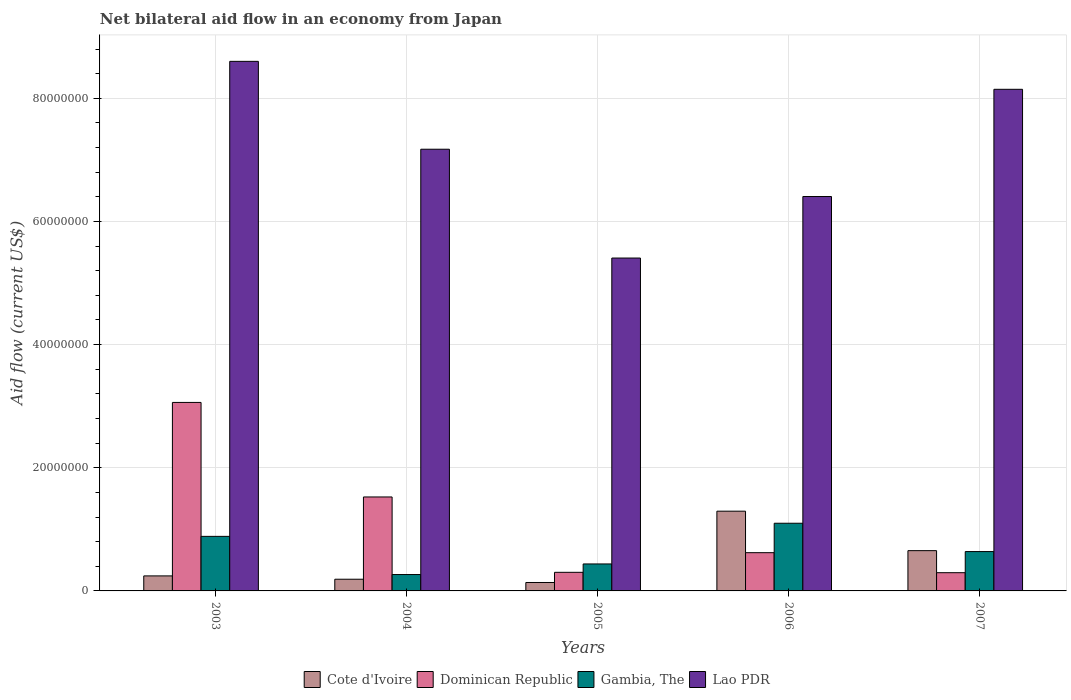How many different coloured bars are there?
Offer a very short reply. 4. How many groups of bars are there?
Give a very brief answer. 5. Are the number of bars per tick equal to the number of legend labels?
Offer a terse response. Yes. What is the label of the 1st group of bars from the left?
Provide a short and direct response. 2003. What is the net bilateral aid flow in Lao PDR in 2004?
Provide a short and direct response. 7.17e+07. Across all years, what is the maximum net bilateral aid flow in Gambia, The?
Provide a succinct answer. 1.10e+07. Across all years, what is the minimum net bilateral aid flow in Gambia, The?
Provide a succinct answer. 2.66e+06. In which year was the net bilateral aid flow in Gambia, The minimum?
Your answer should be very brief. 2004. What is the total net bilateral aid flow in Lao PDR in the graph?
Your response must be concise. 3.57e+08. What is the difference between the net bilateral aid flow in Gambia, The in 2003 and that in 2007?
Offer a very short reply. 2.47e+06. What is the difference between the net bilateral aid flow in Dominican Republic in 2007 and the net bilateral aid flow in Gambia, The in 2003?
Keep it short and to the point. -5.90e+06. What is the average net bilateral aid flow in Dominican Republic per year?
Ensure brevity in your answer.  1.16e+07. In the year 2007, what is the difference between the net bilateral aid flow in Gambia, The and net bilateral aid flow in Cote d'Ivoire?
Make the answer very short. -1.50e+05. What is the ratio of the net bilateral aid flow in Lao PDR in 2004 to that in 2007?
Keep it short and to the point. 0.88. Is the net bilateral aid flow in Cote d'Ivoire in 2003 less than that in 2006?
Offer a terse response. Yes. Is the difference between the net bilateral aid flow in Gambia, The in 2003 and 2004 greater than the difference between the net bilateral aid flow in Cote d'Ivoire in 2003 and 2004?
Provide a short and direct response. Yes. What is the difference between the highest and the second highest net bilateral aid flow in Dominican Republic?
Give a very brief answer. 1.54e+07. What is the difference between the highest and the lowest net bilateral aid flow in Cote d'Ivoire?
Make the answer very short. 1.16e+07. In how many years, is the net bilateral aid flow in Dominican Republic greater than the average net bilateral aid flow in Dominican Republic taken over all years?
Provide a succinct answer. 2. Is the sum of the net bilateral aid flow in Cote d'Ivoire in 2004 and 2006 greater than the maximum net bilateral aid flow in Dominican Republic across all years?
Offer a very short reply. No. What does the 4th bar from the left in 2004 represents?
Provide a succinct answer. Lao PDR. What does the 4th bar from the right in 2006 represents?
Make the answer very short. Cote d'Ivoire. Are all the bars in the graph horizontal?
Give a very brief answer. No. How many years are there in the graph?
Make the answer very short. 5. What is the difference between two consecutive major ticks on the Y-axis?
Your answer should be very brief. 2.00e+07. Are the values on the major ticks of Y-axis written in scientific E-notation?
Your response must be concise. No. Does the graph contain grids?
Your answer should be very brief. Yes. Where does the legend appear in the graph?
Your answer should be compact. Bottom center. What is the title of the graph?
Your answer should be very brief. Net bilateral aid flow in an economy from Japan. Does "Iran" appear as one of the legend labels in the graph?
Give a very brief answer. No. What is the label or title of the Y-axis?
Keep it short and to the point. Aid flow (current US$). What is the Aid flow (current US$) in Cote d'Ivoire in 2003?
Your response must be concise. 2.44e+06. What is the Aid flow (current US$) in Dominican Republic in 2003?
Your response must be concise. 3.06e+07. What is the Aid flow (current US$) in Gambia, The in 2003?
Provide a short and direct response. 8.86e+06. What is the Aid flow (current US$) of Lao PDR in 2003?
Provide a succinct answer. 8.60e+07. What is the Aid flow (current US$) of Cote d'Ivoire in 2004?
Offer a very short reply. 1.90e+06. What is the Aid flow (current US$) of Dominican Republic in 2004?
Provide a short and direct response. 1.53e+07. What is the Aid flow (current US$) in Gambia, The in 2004?
Make the answer very short. 2.66e+06. What is the Aid flow (current US$) of Lao PDR in 2004?
Give a very brief answer. 7.17e+07. What is the Aid flow (current US$) in Cote d'Ivoire in 2005?
Ensure brevity in your answer.  1.37e+06. What is the Aid flow (current US$) in Dominican Republic in 2005?
Your answer should be very brief. 3.02e+06. What is the Aid flow (current US$) of Gambia, The in 2005?
Keep it short and to the point. 4.38e+06. What is the Aid flow (current US$) in Lao PDR in 2005?
Provide a succinct answer. 5.41e+07. What is the Aid flow (current US$) in Cote d'Ivoire in 2006?
Keep it short and to the point. 1.30e+07. What is the Aid flow (current US$) in Dominican Republic in 2006?
Offer a very short reply. 6.21e+06. What is the Aid flow (current US$) in Gambia, The in 2006?
Offer a very short reply. 1.10e+07. What is the Aid flow (current US$) in Lao PDR in 2006?
Offer a terse response. 6.40e+07. What is the Aid flow (current US$) of Cote d'Ivoire in 2007?
Ensure brevity in your answer.  6.54e+06. What is the Aid flow (current US$) in Dominican Republic in 2007?
Your response must be concise. 2.96e+06. What is the Aid flow (current US$) of Gambia, The in 2007?
Make the answer very short. 6.39e+06. What is the Aid flow (current US$) of Lao PDR in 2007?
Give a very brief answer. 8.15e+07. Across all years, what is the maximum Aid flow (current US$) in Cote d'Ivoire?
Provide a short and direct response. 1.30e+07. Across all years, what is the maximum Aid flow (current US$) of Dominican Republic?
Offer a very short reply. 3.06e+07. Across all years, what is the maximum Aid flow (current US$) of Gambia, The?
Your answer should be very brief. 1.10e+07. Across all years, what is the maximum Aid flow (current US$) in Lao PDR?
Give a very brief answer. 8.60e+07. Across all years, what is the minimum Aid flow (current US$) of Cote d'Ivoire?
Make the answer very short. 1.37e+06. Across all years, what is the minimum Aid flow (current US$) in Dominican Republic?
Your answer should be compact. 2.96e+06. Across all years, what is the minimum Aid flow (current US$) in Gambia, The?
Provide a succinct answer. 2.66e+06. Across all years, what is the minimum Aid flow (current US$) of Lao PDR?
Ensure brevity in your answer.  5.41e+07. What is the total Aid flow (current US$) in Cote d'Ivoire in the graph?
Give a very brief answer. 2.52e+07. What is the total Aid flow (current US$) in Dominican Republic in the graph?
Your answer should be compact. 5.81e+07. What is the total Aid flow (current US$) of Gambia, The in the graph?
Offer a very short reply. 3.33e+07. What is the total Aid flow (current US$) in Lao PDR in the graph?
Your answer should be compact. 3.57e+08. What is the difference between the Aid flow (current US$) in Cote d'Ivoire in 2003 and that in 2004?
Your answer should be very brief. 5.40e+05. What is the difference between the Aid flow (current US$) in Dominican Republic in 2003 and that in 2004?
Your answer should be compact. 1.54e+07. What is the difference between the Aid flow (current US$) of Gambia, The in 2003 and that in 2004?
Ensure brevity in your answer.  6.20e+06. What is the difference between the Aid flow (current US$) in Lao PDR in 2003 and that in 2004?
Offer a very short reply. 1.43e+07. What is the difference between the Aid flow (current US$) of Cote d'Ivoire in 2003 and that in 2005?
Offer a terse response. 1.07e+06. What is the difference between the Aid flow (current US$) of Dominican Republic in 2003 and that in 2005?
Your answer should be very brief. 2.76e+07. What is the difference between the Aid flow (current US$) of Gambia, The in 2003 and that in 2005?
Keep it short and to the point. 4.48e+06. What is the difference between the Aid flow (current US$) of Lao PDR in 2003 and that in 2005?
Offer a very short reply. 3.19e+07. What is the difference between the Aid flow (current US$) in Cote d'Ivoire in 2003 and that in 2006?
Your answer should be compact. -1.05e+07. What is the difference between the Aid flow (current US$) in Dominican Republic in 2003 and that in 2006?
Ensure brevity in your answer.  2.44e+07. What is the difference between the Aid flow (current US$) of Gambia, The in 2003 and that in 2006?
Ensure brevity in your answer.  -2.13e+06. What is the difference between the Aid flow (current US$) of Lao PDR in 2003 and that in 2006?
Make the answer very short. 2.20e+07. What is the difference between the Aid flow (current US$) of Cote d'Ivoire in 2003 and that in 2007?
Your response must be concise. -4.10e+06. What is the difference between the Aid flow (current US$) of Dominican Republic in 2003 and that in 2007?
Your response must be concise. 2.76e+07. What is the difference between the Aid flow (current US$) in Gambia, The in 2003 and that in 2007?
Offer a terse response. 2.47e+06. What is the difference between the Aid flow (current US$) in Lao PDR in 2003 and that in 2007?
Keep it short and to the point. 4.54e+06. What is the difference between the Aid flow (current US$) of Cote d'Ivoire in 2004 and that in 2005?
Offer a very short reply. 5.30e+05. What is the difference between the Aid flow (current US$) in Dominican Republic in 2004 and that in 2005?
Make the answer very short. 1.22e+07. What is the difference between the Aid flow (current US$) in Gambia, The in 2004 and that in 2005?
Provide a short and direct response. -1.72e+06. What is the difference between the Aid flow (current US$) in Lao PDR in 2004 and that in 2005?
Provide a short and direct response. 1.77e+07. What is the difference between the Aid flow (current US$) of Cote d'Ivoire in 2004 and that in 2006?
Keep it short and to the point. -1.10e+07. What is the difference between the Aid flow (current US$) of Dominican Republic in 2004 and that in 2006?
Provide a succinct answer. 9.05e+06. What is the difference between the Aid flow (current US$) of Gambia, The in 2004 and that in 2006?
Your answer should be compact. -8.33e+06. What is the difference between the Aid flow (current US$) of Lao PDR in 2004 and that in 2006?
Provide a succinct answer. 7.68e+06. What is the difference between the Aid flow (current US$) in Cote d'Ivoire in 2004 and that in 2007?
Provide a succinct answer. -4.64e+06. What is the difference between the Aid flow (current US$) in Dominican Republic in 2004 and that in 2007?
Keep it short and to the point. 1.23e+07. What is the difference between the Aid flow (current US$) of Gambia, The in 2004 and that in 2007?
Offer a very short reply. -3.73e+06. What is the difference between the Aid flow (current US$) of Lao PDR in 2004 and that in 2007?
Your response must be concise. -9.73e+06. What is the difference between the Aid flow (current US$) of Cote d'Ivoire in 2005 and that in 2006?
Your answer should be very brief. -1.16e+07. What is the difference between the Aid flow (current US$) in Dominican Republic in 2005 and that in 2006?
Provide a succinct answer. -3.19e+06. What is the difference between the Aid flow (current US$) in Gambia, The in 2005 and that in 2006?
Your answer should be compact. -6.61e+06. What is the difference between the Aid flow (current US$) of Lao PDR in 2005 and that in 2006?
Offer a terse response. -9.99e+06. What is the difference between the Aid flow (current US$) of Cote d'Ivoire in 2005 and that in 2007?
Your answer should be very brief. -5.17e+06. What is the difference between the Aid flow (current US$) of Dominican Republic in 2005 and that in 2007?
Make the answer very short. 6.00e+04. What is the difference between the Aid flow (current US$) in Gambia, The in 2005 and that in 2007?
Provide a succinct answer. -2.01e+06. What is the difference between the Aid flow (current US$) of Lao PDR in 2005 and that in 2007?
Offer a terse response. -2.74e+07. What is the difference between the Aid flow (current US$) in Cote d'Ivoire in 2006 and that in 2007?
Offer a very short reply. 6.41e+06. What is the difference between the Aid flow (current US$) of Dominican Republic in 2006 and that in 2007?
Your answer should be compact. 3.25e+06. What is the difference between the Aid flow (current US$) of Gambia, The in 2006 and that in 2007?
Offer a terse response. 4.60e+06. What is the difference between the Aid flow (current US$) in Lao PDR in 2006 and that in 2007?
Give a very brief answer. -1.74e+07. What is the difference between the Aid flow (current US$) of Cote d'Ivoire in 2003 and the Aid flow (current US$) of Dominican Republic in 2004?
Offer a very short reply. -1.28e+07. What is the difference between the Aid flow (current US$) of Cote d'Ivoire in 2003 and the Aid flow (current US$) of Gambia, The in 2004?
Give a very brief answer. -2.20e+05. What is the difference between the Aid flow (current US$) in Cote d'Ivoire in 2003 and the Aid flow (current US$) in Lao PDR in 2004?
Provide a short and direct response. -6.93e+07. What is the difference between the Aid flow (current US$) in Dominican Republic in 2003 and the Aid flow (current US$) in Gambia, The in 2004?
Keep it short and to the point. 2.80e+07. What is the difference between the Aid flow (current US$) in Dominican Republic in 2003 and the Aid flow (current US$) in Lao PDR in 2004?
Keep it short and to the point. -4.11e+07. What is the difference between the Aid flow (current US$) of Gambia, The in 2003 and the Aid flow (current US$) of Lao PDR in 2004?
Keep it short and to the point. -6.29e+07. What is the difference between the Aid flow (current US$) in Cote d'Ivoire in 2003 and the Aid flow (current US$) in Dominican Republic in 2005?
Make the answer very short. -5.80e+05. What is the difference between the Aid flow (current US$) of Cote d'Ivoire in 2003 and the Aid flow (current US$) of Gambia, The in 2005?
Keep it short and to the point. -1.94e+06. What is the difference between the Aid flow (current US$) in Cote d'Ivoire in 2003 and the Aid flow (current US$) in Lao PDR in 2005?
Keep it short and to the point. -5.16e+07. What is the difference between the Aid flow (current US$) of Dominican Republic in 2003 and the Aid flow (current US$) of Gambia, The in 2005?
Offer a very short reply. 2.62e+07. What is the difference between the Aid flow (current US$) of Dominican Republic in 2003 and the Aid flow (current US$) of Lao PDR in 2005?
Your response must be concise. -2.34e+07. What is the difference between the Aid flow (current US$) in Gambia, The in 2003 and the Aid flow (current US$) in Lao PDR in 2005?
Offer a very short reply. -4.52e+07. What is the difference between the Aid flow (current US$) of Cote d'Ivoire in 2003 and the Aid flow (current US$) of Dominican Republic in 2006?
Your answer should be compact. -3.77e+06. What is the difference between the Aid flow (current US$) in Cote d'Ivoire in 2003 and the Aid flow (current US$) in Gambia, The in 2006?
Make the answer very short. -8.55e+06. What is the difference between the Aid flow (current US$) in Cote d'Ivoire in 2003 and the Aid flow (current US$) in Lao PDR in 2006?
Give a very brief answer. -6.16e+07. What is the difference between the Aid flow (current US$) of Dominican Republic in 2003 and the Aid flow (current US$) of Gambia, The in 2006?
Make the answer very short. 1.96e+07. What is the difference between the Aid flow (current US$) of Dominican Republic in 2003 and the Aid flow (current US$) of Lao PDR in 2006?
Ensure brevity in your answer.  -3.34e+07. What is the difference between the Aid flow (current US$) in Gambia, The in 2003 and the Aid flow (current US$) in Lao PDR in 2006?
Your response must be concise. -5.52e+07. What is the difference between the Aid flow (current US$) of Cote d'Ivoire in 2003 and the Aid flow (current US$) of Dominican Republic in 2007?
Make the answer very short. -5.20e+05. What is the difference between the Aid flow (current US$) in Cote d'Ivoire in 2003 and the Aid flow (current US$) in Gambia, The in 2007?
Keep it short and to the point. -3.95e+06. What is the difference between the Aid flow (current US$) in Cote d'Ivoire in 2003 and the Aid flow (current US$) in Lao PDR in 2007?
Ensure brevity in your answer.  -7.90e+07. What is the difference between the Aid flow (current US$) in Dominican Republic in 2003 and the Aid flow (current US$) in Gambia, The in 2007?
Make the answer very short. 2.42e+07. What is the difference between the Aid flow (current US$) in Dominican Republic in 2003 and the Aid flow (current US$) in Lao PDR in 2007?
Offer a terse response. -5.08e+07. What is the difference between the Aid flow (current US$) of Gambia, The in 2003 and the Aid flow (current US$) of Lao PDR in 2007?
Your answer should be very brief. -7.26e+07. What is the difference between the Aid flow (current US$) in Cote d'Ivoire in 2004 and the Aid flow (current US$) in Dominican Republic in 2005?
Keep it short and to the point. -1.12e+06. What is the difference between the Aid flow (current US$) of Cote d'Ivoire in 2004 and the Aid flow (current US$) of Gambia, The in 2005?
Ensure brevity in your answer.  -2.48e+06. What is the difference between the Aid flow (current US$) in Cote d'Ivoire in 2004 and the Aid flow (current US$) in Lao PDR in 2005?
Offer a terse response. -5.22e+07. What is the difference between the Aid flow (current US$) in Dominican Republic in 2004 and the Aid flow (current US$) in Gambia, The in 2005?
Offer a very short reply. 1.09e+07. What is the difference between the Aid flow (current US$) in Dominican Republic in 2004 and the Aid flow (current US$) in Lao PDR in 2005?
Provide a short and direct response. -3.88e+07. What is the difference between the Aid flow (current US$) in Gambia, The in 2004 and the Aid flow (current US$) in Lao PDR in 2005?
Your answer should be compact. -5.14e+07. What is the difference between the Aid flow (current US$) of Cote d'Ivoire in 2004 and the Aid flow (current US$) of Dominican Republic in 2006?
Your response must be concise. -4.31e+06. What is the difference between the Aid flow (current US$) in Cote d'Ivoire in 2004 and the Aid flow (current US$) in Gambia, The in 2006?
Keep it short and to the point. -9.09e+06. What is the difference between the Aid flow (current US$) in Cote d'Ivoire in 2004 and the Aid flow (current US$) in Lao PDR in 2006?
Provide a succinct answer. -6.22e+07. What is the difference between the Aid flow (current US$) of Dominican Republic in 2004 and the Aid flow (current US$) of Gambia, The in 2006?
Provide a short and direct response. 4.27e+06. What is the difference between the Aid flow (current US$) of Dominican Republic in 2004 and the Aid flow (current US$) of Lao PDR in 2006?
Offer a terse response. -4.88e+07. What is the difference between the Aid flow (current US$) of Gambia, The in 2004 and the Aid flow (current US$) of Lao PDR in 2006?
Your answer should be very brief. -6.14e+07. What is the difference between the Aid flow (current US$) of Cote d'Ivoire in 2004 and the Aid flow (current US$) of Dominican Republic in 2007?
Your response must be concise. -1.06e+06. What is the difference between the Aid flow (current US$) in Cote d'Ivoire in 2004 and the Aid flow (current US$) in Gambia, The in 2007?
Offer a very short reply. -4.49e+06. What is the difference between the Aid flow (current US$) in Cote d'Ivoire in 2004 and the Aid flow (current US$) in Lao PDR in 2007?
Keep it short and to the point. -7.96e+07. What is the difference between the Aid flow (current US$) in Dominican Republic in 2004 and the Aid flow (current US$) in Gambia, The in 2007?
Ensure brevity in your answer.  8.87e+06. What is the difference between the Aid flow (current US$) in Dominican Republic in 2004 and the Aid flow (current US$) in Lao PDR in 2007?
Your answer should be compact. -6.62e+07. What is the difference between the Aid flow (current US$) in Gambia, The in 2004 and the Aid flow (current US$) in Lao PDR in 2007?
Your answer should be very brief. -7.88e+07. What is the difference between the Aid flow (current US$) of Cote d'Ivoire in 2005 and the Aid flow (current US$) of Dominican Republic in 2006?
Your answer should be compact. -4.84e+06. What is the difference between the Aid flow (current US$) in Cote d'Ivoire in 2005 and the Aid flow (current US$) in Gambia, The in 2006?
Make the answer very short. -9.62e+06. What is the difference between the Aid flow (current US$) in Cote d'Ivoire in 2005 and the Aid flow (current US$) in Lao PDR in 2006?
Ensure brevity in your answer.  -6.27e+07. What is the difference between the Aid flow (current US$) of Dominican Republic in 2005 and the Aid flow (current US$) of Gambia, The in 2006?
Offer a terse response. -7.97e+06. What is the difference between the Aid flow (current US$) in Dominican Republic in 2005 and the Aid flow (current US$) in Lao PDR in 2006?
Provide a succinct answer. -6.10e+07. What is the difference between the Aid flow (current US$) of Gambia, The in 2005 and the Aid flow (current US$) of Lao PDR in 2006?
Your answer should be very brief. -5.97e+07. What is the difference between the Aid flow (current US$) of Cote d'Ivoire in 2005 and the Aid flow (current US$) of Dominican Republic in 2007?
Your answer should be very brief. -1.59e+06. What is the difference between the Aid flow (current US$) of Cote d'Ivoire in 2005 and the Aid flow (current US$) of Gambia, The in 2007?
Your answer should be compact. -5.02e+06. What is the difference between the Aid flow (current US$) in Cote d'Ivoire in 2005 and the Aid flow (current US$) in Lao PDR in 2007?
Keep it short and to the point. -8.01e+07. What is the difference between the Aid flow (current US$) in Dominican Republic in 2005 and the Aid flow (current US$) in Gambia, The in 2007?
Make the answer very short. -3.37e+06. What is the difference between the Aid flow (current US$) in Dominican Republic in 2005 and the Aid flow (current US$) in Lao PDR in 2007?
Keep it short and to the point. -7.84e+07. What is the difference between the Aid flow (current US$) of Gambia, The in 2005 and the Aid flow (current US$) of Lao PDR in 2007?
Provide a succinct answer. -7.71e+07. What is the difference between the Aid flow (current US$) in Cote d'Ivoire in 2006 and the Aid flow (current US$) in Dominican Republic in 2007?
Your response must be concise. 9.99e+06. What is the difference between the Aid flow (current US$) of Cote d'Ivoire in 2006 and the Aid flow (current US$) of Gambia, The in 2007?
Your answer should be compact. 6.56e+06. What is the difference between the Aid flow (current US$) of Cote d'Ivoire in 2006 and the Aid flow (current US$) of Lao PDR in 2007?
Provide a short and direct response. -6.85e+07. What is the difference between the Aid flow (current US$) in Dominican Republic in 2006 and the Aid flow (current US$) in Gambia, The in 2007?
Offer a very short reply. -1.80e+05. What is the difference between the Aid flow (current US$) in Dominican Republic in 2006 and the Aid flow (current US$) in Lao PDR in 2007?
Give a very brief answer. -7.52e+07. What is the difference between the Aid flow (current US$) of Gambia, The in 2006 and the Aid flow (current US$) of Lao PDR in 2007?
Give a very brief answer. -7.05e+07. What is the average Aid flow (current US$) in Cote d'Ivoire per year?
Provide a short and direct response. 5.04e+06. What is the average Aid flow (current US$) in Dominican Republic per year?
Offer a very short reply. 1.16e+07. What is the average Aid flow (current US$) of Gambia, The per year?
Your response must be concise. 6.66e+06. What is the average Aid flow (current US$) of Lao PDR per year?
Your answer should be very brief. 7.15e+07. In the year 2003, what is the difference between the Aid flow (current US$) in Cote d'Ivoire and Aid flow (current US$) in Dominican Republic?
Your answer should be compact. -2.82e+07. In the year 2003, what is the difference between the Aid flow (current US$) of Cote d'Ivoire and Aid flow (current US$) of Gambia, The?
Make the answer very short. -6.42e+06. In the year 2003, what is the difference between the Aid flow (current US$) in Cote d'Ivoire and Aid flow (current US$) in Lao PDR?
Offer a very short reply. -8.36e+07. In the year 2003, what is the difference between the Aid flow (current US$) in Dominican Republic and Aid flow (current US$) in Gambia, The?
Your answer should be very brief. 2.18e+07. In the year 2003, what is the difference between the Aid flow (current US$) of Dominican Republic and Aid flow (current US$) of Lao PDR?
Provide a succinct answer. -5.54e+07. In the year 2003, what is the difference between the Aid flow (current US$) of Gambia, The and Aid flow (current US$) of Lao PDR?
Make the answer very short. -7.71e+07. In the year 2004, what is the difference between the Aid flow (current US$) in Cote d'Ivoire and Aid flow (current US$) in Dominican Republic?
Offer a terse response. -1.34e+07. In the year 2004, what is the difference between the Aid flow (current US$) in Cote d'Ivoire and Aid flow (current US$) in Gambia, The?
Your response must be concise. -7.60e+05. In the year 2004, what is the difference between the Aid flow (current US$) of Cote d'Ivoire and Aid flow (current US$) of Lao PDR?
Ensure brevity in your answer.  -6.98e+07. In the year 2004, what is the difference between the Aid flow (current US$) of Dominican Republic and Aid flow (current US$) of Gambia, The?
Offer a terse response. 1.26e+07. In the year 2004, what is the difference between the Aid flow (current US$) of Dominican Republic and Aid flow (current US$) of Lao PDR?
Keep it short and to the point. -5.65e+07. In the year 2004, what is the difference between the Aid flow (current US$) in Gambia, The and Aid flow (current US$) in Lao PDR?
Your answer should be compact. -6.91e+07. In the year 2005, what is the difference between the Aid flow (current US$) in Cote d'Ivoire and Aid flow (current US$) in Dominican Republic?
Ensure brevity in your answer.  -1.65e+06. In the year 2005, what is the difference between the Aid flow (current US$) of Cote d'Ivoire and Aid flow (current US$) of Gambia, The?
Provide a succinct answer. -3.01e+06. In the year 2005, what is the difference between the Aid flow (current US$) in Cote d'Ivoire and Aid flow (current US$) in Lao PDR?
Provide a short and direct response. -5.27e+07. In the year 2005, what is the difference between the Aid flow (current US$) of Dominican Republic and Aid flow (current US$) of Gambia, The?
Keep it short and to the point. -1.36e+06. In the year 2005, what is the difference between the Aid flow (current US$) in Dominican Republic and Aid flow (current US$) in Lao PDR?
Your answer should be very brief. -5.10e+07. In the year 2005, what is the difference between the Aid flow (current US$) in Gambia, The and Aid flow (current US$) in Lao PDR?
Make the answer very short. -4.97e+07. In the year 2006, what is the difference between the Aid flow (current US$) of Cote d'Ivoire and Aid flow (current US$) of Dominican Republic?
Offer a terse response. 6.74e+06. In the year 2006, what is the difference between the Aid flow (current US$) of Cote d'Ivoire and Aid flow (current US$) of Gambia, The?
Your response must be concise. 1.96e+06. In the year 2006, what is the difference between the Aid flow (current US$) in Cote d'Ivoire and Aid flow (current US$) in Lao PDR?
Make the answer very short. -5.11e+07. In the year 2006, what is the difference between the Aid flow (current US$) in Dominican Republic and Aid flow (current US$) in Gambia, The?
Provide a short and direct response. -4.78e+06. In the year 2006, what is the difference between the Aid flow (current US$) of Dominican Republic and Aid flow (current US$) of Lao PDR?
Make the answer very short. -5.78e+07. In the year 2006, what is the difference between the Aid flow (current US$) in Gambia, The and Aid flow (current US$) in Lao PDR?
Make the answer very short. -5.31e+07. In the year 2007, what is the difference between the Aid flow (current US$) of Cote d'Ivoire and Aid flow (current US$) of Dominican Republic?
Make the answer very short. 3.58e+06. In the year 2007, what is the difference between the Aid flow (current US$) of Cote d'Ivoire and Aid flow (current US$) of Lao PDR?
Make the answer very short. -7.49e+07. In the year 2007, what is the difference between the Aid flow (current US$) in Dominican Republic and Aid flow (current US$) in Gambia, The?
Give a very brief answer. -3.43e+06. In the year 2007, what is the difference between the Aid flow (current US$) of Dominican Republic and Aid flow (current US$) of Lao PDR?
Offer a very short reply. -7.85e+07. In the year 2007, what is the difference between the Aid flow (current US$) in Gambia, The and Aid flow (current US$) in Lao PDR?
Provide a succinct answer. -7.51e+07. What is the ratio of the Aid flow (current US$) in Cote d'Ivoire in 2003 to that in 2004?
Your answer should be compact. 1.28. What is the ratio of the Aid flow (current US$) of Dominican Republic in 2003 to that in 2004?
Provide a short and direct response. 2.01. What is the ratio of the Aid flow (current US$) of Gambia, The in 2003 to that in 2004?
Ensure brevity in your answer.  3.33. What is the ratio of the Aid flow (current US$) of Lao PDR in 2003 to that in 2004?
Ensure brevity in your answer.  1.2. What is the ratio of the Aid flow (current US$) of Cote d'Ivoire in 2003 to that in 2005?
Your answer should be compact. 1.78. What is the ratio of the Aid flow (current US$) in Dominican Republic in 2003 to that in 2005?
Your response must be concise. 10.14. What is the ratio of the Aid flow (current US$) of Gambia, The in 2003 to that in 2005?
Keep it short and to the point. 2.02. What is the ratio of the Aid flow (current US$) in Lao PDR in 2003 to that in 2005?
Offer a very short reply. 1.59. What is the ratio of the Aid flow (current US$) of Cote d'Ivoire in 2003 to that in 2006?
Ensure brevity in your answer.  0.19. What is the ratio of the Aid flow (current US$) in Dominican Republic in 2003 to that in 2006?
Give a very brief answer. 4.93. What is the ratio of the Aid flow (current US$) in Gambia, The in 2003 to that in 2006?
Give a very brief answer. 0.81. What is the ratio of the Aid flow (current US$) in Lao PDR in 2003 to that in 2006?
Offer a terse response. 1.34. What is the ratio of the Aid flow (current US$) in Cote d'Ivoire in 2003 to that in 2007?
Make the answer very short. 0.37. What is the ratio of the Aid flow (current US$) of Dominican Republic in 2003 to that in 2007?
Your response must be concise. 10.34. What is the ratio of the Aid flow (current US$) of Gambia, The in 2003 to that in 2007?
Your response must be concise. 1.39. What is the ratio of the Aid flow (current US$) in Lao PDR in 2003 to that in 2007?
Your answer should be very brief. 1.06. What is the ratio of the Aid flow (current US$) in Cote d'Ivoire in 2004 to that in 2005?
Provide a short and direct response. 1.39. What is the ratio of the Aid flow (current US$) in Dominican Republic in 2004 to that in 2005?
Provide a succinct answer. 5.05. What is the ratio of the Aid flow (current US$) of Gambia, The in 2004 to that in 2005?
Make the answer very short. 0.61. What is the ratio of the Aid flow (current US$) of Lao PDR in 2004 to that in 2005?
Make the answer very short. 1.33. What is the ratio of the Aid flow (current US$) in Cote d'Ivoire in 2004 to that in 2006?
Make the answer very short. 0.15. What is the ratio of the Aid flow (current US$) in Dominican Republic in 2004 to that in 2006?
Provide a succinct answer. 2.46. What is the ratio of the Aid flow (current US$) in Gambia, The in 2004 to that in 2006?
Offer a terse response. 0.24. What is the ratio of the Aid flow (current US$) of Lao PDR in 2004 to that in 2006?
Ensure brevity in your answer.  1.12. What is the ratio of the Aid flow (current US$) in Cote d'Ivoire in 2004 to that in 2007?
Make the answer very short. 0.29. What is the ratio of the Aid flow (current US$) of Dominican Republic in 2004 to that in 2007?
Ensure brevity in your answer.  5.16. What is the ratio of the Aid flow (current US$) in Gambia, The in 2004 to that in 2007?
Keep it short and to the point. 0.42. What is the ratio of the Aid flow (current US$) of Lao PDR in 2004 to that in 2007?
Your answer should be compact. 0.88. What is the ratio of the Aid flow (current US$) in Cote d'Ivoire in 2005 to that in 2006?
Make the answer very short. 0.11. What is the ratio of the Aid flow (current US$) of Dominican Republic in 2005 to that in 2006?
Your answer should be very brief. 0.49. What is the ratio of the Aid flow (current US$) in Gambia, The in 2005 to that in 2006?
Offer a terse response. 0.4. What is the ratio of the Aid flow (current US$) in Lao PDR in 2005 to that in 2006?
Ensure brevity in your answer.  0.84. What is the ratio of the Aid flow (current US$) in Cote d'Ivoire in 2005 to that in 2007?
Your answer should be compact. 0.21. What is the ratio of the Aid flow (current US$) of Dominican Republic in 2005 to that in 2007?
Ensure brevity in your answer.  1.02. What is the ratio of the Aid flow (current US$) in Gambia, The in 2005 to that in 2007?
Make the answer very short. 0.69. What is the ratio of the Aid flow (current US$) in Lao PDR in 2005 to that in 2007?
Your answer should be very brief. 0.66. What is the ratio of the Aid flow (current US$) in Cote d'Ivoire in 2006 to that in 2007?
Give a very brief answer. 1.98. What is the ratio of the Aid flow (current US$) of Dominican Republic in 2006 to that in 2007?
Provide a short and direct response. 2.1. What is the ratio of the Aid flow (current US$) in Gambia, The in 2006 to that in 2007?
Make the answer very short. 1.72. What is the ratio of the Aid flow (current US$) in Lao PDR in 2006 to that in 2007?
Keep it short and to the point. 0.79. What is the difference between the highest and the second highest Aid flow (current US$) in Cote d'Ivoire?
Your answer should be very brief. 6.41e+06. What is the difference between the highest and the second highest Aid flow (current US$) in Dominican Republic?
Provide a short and direct response. 1.54e+07. What is the difference between the highest and the second highest Aid flow (current US$) in Gambia, The?
Provide a short and direct response. 2.13e+06. What is the difference between the highest and the second highest Aid flow (current US$) in Lao PDR?
Offer a very short reply. 4.54e+06. What is the difference between the highest and the lowest Aid flow (current US$) in Cote d'Ivoire?
Your response must be concise. 1.16e+07. What is the difference between the highest and the lowest Aid flow (current US$) in Dominican Republic?
Keep it short and to the point. 2.76e+07. What is the difference between the highest and the lowest Aid flow (current US$) in Gambia, The?
Offer a terse response. 8.33e+06. What is the difference between the highest and the lowest Aid flow (current US$) in Lao PDR?
Provide a succinct answer. 3.19e+07. 